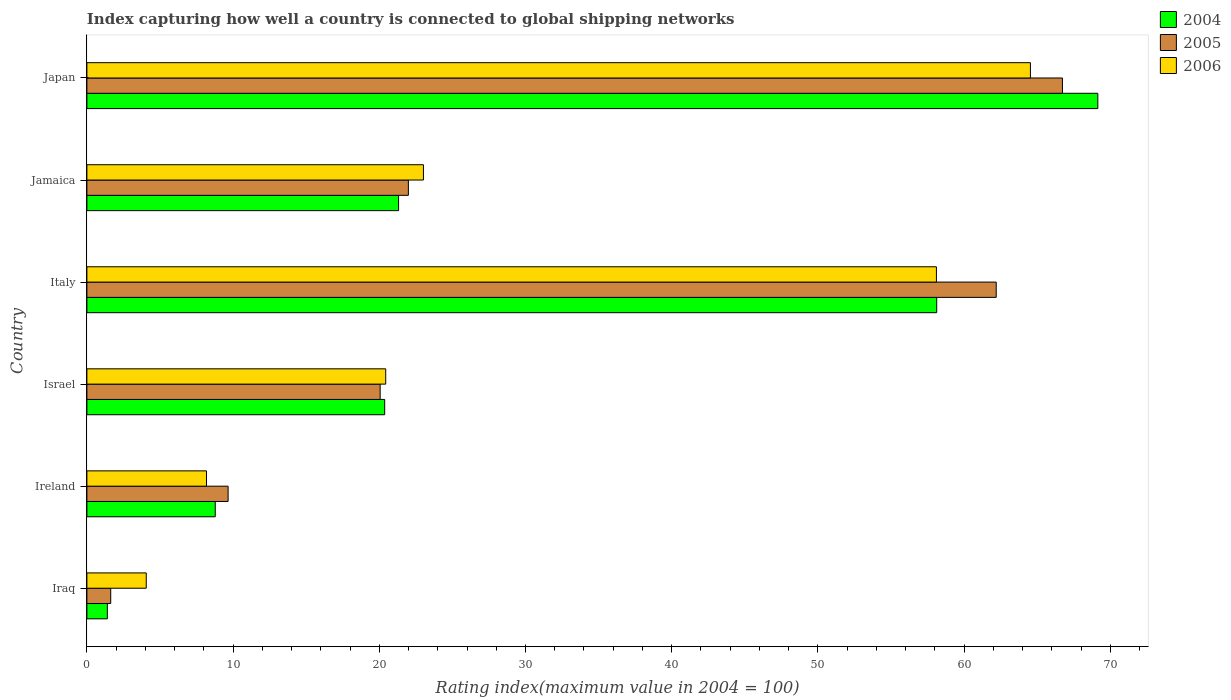How many different coloured bars are there?
Provide a succinct answer. 3. How many groups of bars are there?
Offer a terse response. 6. Are the number of bars on each tick of the Y-axis equal?
Provide a short and direct response. Yes. How many bars are there on the 6th tick from the bottom?
Provide a succinct answer. 3. What is the label of the 6th group of bars from the top?
Give a very brief answer. Iraq. What is the rating index in 2004 in Japan?
Offer a very short reply. 69.15. Across all countries, what is the maximum rating index in 2005?
Provide a short and direct response. 66.73. Across all countries, what is the minimum rating index in 2005?
Your response must be concise. 1.63. In which country was the rating index in 2004 maximum?
Offer a terse response. Japan. In which country was the rating index in 2005 minimum?
Keep it short and to the point. Iraq. What is the total rating index in 2006 in the graph?
Ensure brevity in your answer.  178.35. What is the difference between the rating index in 2004 in Israel and that in Japan?
Make the answer very short. -48.78. What is the difference between the rating index in 2006 in Italy and the rating index in 2005 in Ireland?
Give a very brief answer. 48.45. What is the average rating index in 2006 per country?
Your answer should be very brief. 29.72. What is the difference between the rating index in 2005 and rating index in 2006 in Jamaica?
Provide a short and direct response. -1.03. What is the ratio of the rating index in 2005 in Iraq to that in Jamaica?
Offer a very short reply. 0.07. Is the rating index in 2004 in Israel less than that in Jamaica?
Your answer should be compact. Yes. What is the difference between the highest and the second highest rating index in 2006?
Provide a succinct answer. 6.43. What is the difference between the highest and the lowest rating index in 2006?
Your answer should be very brief. 60.48. In how many countries, is the rating index in 2005 greater than the average rating index in 2005 taken over all countries?
Offer a terse response. 2. Is the sum of the rating index in 2006 in Israel and Jamaica greater than the maximum rating index in 2004 across all countries?
Offer a terse response. No. What does the 2nd bar from the bottom in Iraq represents?
Offer a very short reply. 2005. Is it the case that in every country, the sum of the rating index in 2006 and rating index in 2004 is greater than the rating index in 2005?
Provide a succinct answer. Yes. How many bars are there?
Your answer should be compact. 18. How many countries are there in the graph?
Your response must be concise. 6. Are the values on the major ticks of X-axis written in scientific E-notation?
Give a very brief answer. No. Does the graph contain any zero values?
Offer a terse response. No. What is the title of the graph?
Your answer should be very brief. Index capturing how well a country is connected to global shipping networks. What is the label or title of the X-axis?
Give a very brief answer. Rating index(maximum value in 2004 = 100). What is the Rating index(maximum value in 2004 = 100) of 2004 in Iraq?
Provide a short and direct response. 1.4. What is the Rating index(maximum value in 2004 = 100) in 2005 in Iraq?
Offer a terse response. 1.63. What is the Rating index(maximum value in 2004 = 100) in 2006 in Iraq?
Your answer should be compact. 4.06. What is the Rating index(maximum value in 2004 = 100) of 2004 in Ireland?
Keep it short and to the point. 8.78. What is the Rating index(maximum value in 2004 = 100) in 2005 in Ireland?
Offer a terse response. 9.66. What is the Rating index(maximum value in 2004 = 100) of 2006 in Ireland?
Your response must be concise. 8.18. What is the Rating index(maximum value in 2004 = 100) of 2004 in Israel?
Your answer should be very brief. 20.37. What is the Rating index(maximum value in 2004 = 100) in 2005 in Israel?
Make the answer very short. 20.06. What is the Rating index(maximum value in 2004 = 100) of 2006 in Israel?
Ensure brevity in your answer.  20.44. What is the Rating index(maximum value in 2004 = 100) of 2004 in Italy?
Offer a very short reply. 58.13. What is the Rating index(maximum value in 2004 = 100) of 2005 in Italy?
Your response must be concise. 62.2. What is the Rating index(maximum value in 2004 = 100) in 2006 in Italy?
Ensure brevity in your answer.  58.11. What is the Rating index(maximum value in 2004 = 100) of 2004 in Jamaica?
Offer a terse response. 21.32. What is the Rating index(maximum value in 2004 = 100) in 2005 in Jamaica?
Provide a succinct answer. 21.99. What is the Rating index(maximum value in 2004 = 100) in 2006 in Jamaica?
Your answer should be compact. 23.02. What is the Rating index(maximum value in 2004 = 100) in 2004 in Japan?
Offer a very short reply. 69.15. What is the Rating index(maximum value in 2004 = 100) in 2005 in Japan?
Offer a very short reply. 66.73. What is the Rating index(maximum value in 2004 = 100) in 2006 in Japan?
Keep it short and to the point. 64.54. Across all countries, what is the maximum Rating index(maximum value in 2004 = 100) in 2004?
Your response must be concise. 69.15. Across all countries, what is the maximum Rating index(maximum value in 2004 = 100) of 2005?
Your answer should be very brief. 66.73. Across all countries, what is the maximum Rating index(maximum value in 2004 = 100) in 2006?
Provide a succinct answer. 64.54. Across all countries, what is the minimum Rating index(maximum value in 2004 = 100) in 2005?
Offer a terse response. 1.63. Across all countries, what is the minimum Rating index(maximum value in 2004 = 100) of 2006?
Your answer should be compact. 4.06. What is the total Rating index(maximum value in 2004 = 100) of 2004 in the graph?
Provide a short and direct response. 179.15. What is the total Rating index(maximum value in 2004 = 100) of 2005 in the graph?
Offer a terse response. 182.27. What is the total Rating index(maximum value in 2004 = 100) of 2006 in the graph?
Your answer should be compact. 178.35. What is the difference between the Rating index(maximum value in 2004 = 100) of 2004 in Iraq and that in Ireland?
Your response must be concise. -7.38. What is the difference between the Rating index(maximum value in 2004 = 100) in 2005 in Iraq and that in Ireland?
Ensure brevity in your answer.  -8.03. What is the difference between the Rating index(maximum value in 2004 = 100) in 2006 in Iraq and that in Ireland?
Offer a very short reply. -4.12. What is the difference between the Rating index(maximum value in 2004 = 100) in 2004 in Iraq and that in Israel?
Provide a succinct answer. -18.97. What is the difference between the Rating index(maximum value in 2004 = 100) in 2005 in Iraq and that in Israel?
Give a very brief answer. -18.43. What is the difference between the Rating index(maximum value in 2004 = 100) in 2006 in Iraq and that in Israel?
Your answer should be very brief. -16.38. What is the difference between the Rating index(maximum value in 2004 = 100) in 2004 in Iraq and that in Italy?
Offer a terse response. -56.73. What is the difference between the Rating index(maximum value in 2004 = 100) of 2005 in Iraq and that in Italy?
Your answer should be very brief. -60.57. What is the difference between the Rating index(maximum value in 2004 = 100) of 2006 in Iraq and that in Italy?
Provide a succinct answer. -54.05. What is the difference between the Rating index(maximum value in 2004 = 100) in 2004 in Iraq and that in Jamaica?
Offer a very short reply. -19.92. What is the difference between the Rating index(maximum value in 2004 = 100) of 2005 in Iraq and that in Jamaica?
Offer a very short reply. -20.36. What is the difference between the Rating index(maximum value in 2004 = 100) of 2006 in Iraq and that in Jamaica?
Ensure brevity in your answer.  -18.96. What is the difference between the Rating index(maximum value in 2004 = 100) of 2004 in Iraq and that in Japan?
Give a very brief answer. -67.75. What is the difference between the Rating index(maximum value in 2004 = 100) in 2005 in Iraq and that in Japan?
Your answer should be compact. -65.1. What is the difference between the Rating index(maximum value in 2004 = 100) of 2006 in Iraq and that in Japan?
Offer a terse response. -60.48. What is the difference between the Rating index(maximum value in 2004 = 100) of 2004 in Ireland and that in Israel?
Your answer should be very brief. -11.59. What is the difference between the Rating index(maximum value in 2004 = 100) in 2006 in Ireland and that in Israel?
Your answer should be very brief. -12.26. What is the difference between the Rating index(maximum value in 2004 = 100) of 2004 in Ireland and that in Italy?
Give a very brief answer. -49.35. What is the difference between the Rating index(maximum value in 2004 = 100) of 2005 in Ireland and that in Italy?
Your answer should be compact. -52.54. What is the difference between the Rating index(maximum value in 2004 = 100) in 2006 in Ireland and that in Italy?
Provide a short and direct response. -49.93. What is the difference between the Rating index(maximum value in 2004 = 100) in 2004 in Ireland and that in Jamaica?
Your answer should be very brief. -12.54. What is the difference between the Rating index(maximum value in 2004 = 100) in 2005 in Ireland and that in Jamaica?
Offer a very short reply. -12.33. What is the difference between the Rating index(maximum value in 2004 = 100) of 2006 in Ireland and that in Jamaica?
Your answer should be compact. -14.84. What is the difference between the Rating index(maximum value in 2004 = 100) in 2004 in Ireland and that in Japan?
Your response must be concise. -60.37. What is the difference between the Rating index(maximum value in 2004 = 100) in 2005 in Ireland and that in Japan?
Your response must be concise. -57.07. What is the difference between the Rating index(maximum value in 2004 = 100) in 2006 in Ireland and that in Japan?
Provide a short and direct response. -56.36. What is the difference between the Rating index(maximum value in 2004 = 100) in 2004 in Israel and that in Italy?
Give a very brief answer. -37.76. What is the difference between the Rating index(maximum value in 2004 = 100) in 2005 in Israel and that in Italy?
Your answer should be very brief. -42.14. What is the difference between the Rating index(maximum value in 2004 = 100) in 2006 in Israel and that in Italy?
Your answer should be compact. -37.67. What is the difference between the Rating index(maximum value in 2004 = 100) of 2004 in Israel and that in Jamaica?
Keep it short and to the point. -0.95. What is the difference between the Rating index(maximum value in 2004 = 100) in 2005 in Israel and that in Jamaica?
Your answer should be compact. -1.93. What is the difference between the Rating index(maximum value in 2004 = 100) of 2006 in Israel and that in Jamaica?
Keep it short and to the point. -2.58. What is the difference between the Rating index(maximum value in 2004 = 100) of 2004 in Israel and that in Japan?
Provide a succinct answer. -48.78. What is the difference between the Rating index(maximum value in 2004 = 100) of 2005 in Israel and that in Japan?
Your answer should be compact. -46.67. What is the difference between the Rating index(maximum value in 2004 = 100) of 2006 in Israel and that in Japan?
Your answer should be very brief. -44.1. What is the difference between the Rating index(maximum value in 2004 = 100) in 2004 in Italy and that in Jamaica?
Offer a terse response. 36.81. What is the difference between the Rating index(maximum value in 2004 = 100) of 2005 in Italy and that in Jamaica?
Your answer should be compact. 40.21. What is the difference between the Rating index(maximum value in 2004 = 100) in 2006 in Italy and that in Jamaica?
Your response must be concise. 35.09. What is the difference between the Rating index(maximum value in 2004 = 100) in 2004 in Italy and that in Japan?
Give a very brief answer. -11.02. What is the difference between the Rating index(maximum value in 2004 = 100) of 2005 in Italy and that in Japan?
Provide a succinct answer. -4.53. What is the difference between the Rating index(maximum value in 2004 = 100) in 2006 in Italy and that in Japan?
Provide a short and direct response. -6.43. What is the difference between the Rating index(maximum value in 2004 = 100) of 2004 in Jamaica and that in Japan?
Offer a very short reply. -47.83. What is the difference between the Rating index(maximum value in 2004 = 100) in 2005 in Jamaica and that in Japan?
Provide a short and direct response. -44.74. What is the difference between the Rating index(maximum value in 2004 = 100) of 2006 in Jamaica and that in Japan?
Ensure brevity in your answer.  -41.52. What is the difference between the Rating index(maximum value in 2004 = 100) in 2004 in Iraq and the Rating index(maximum value in 2004 = 100) in 2005 in Ireland?
Offer a terse response. -8.26. What is the difference between the Rating index(maximum value in 2004 = 100) in 2004 in Iraq and the Rating index(maximum value in 2004 = 100) in 2006 in Ireland?
Keep it short and to the point. -6.78. What is the difference between the Rating index(maximum value in 2004 = 100) in 2005 in Iraq and the Rating index(maximum value in 2004 = 100) in 2006 in Ireland?
Give a very brief answer. -6.55. What is the difference between the Rating index(maximum value in 2004 = 100) of 2004 in Iraq and the Rating index(maximum value in 2004 = 100) of 2005 in Israel?
Offer a very short reply. -18.66. What is the difference between the Rating index(maximum value in 2004 = 100) of 2004 in Iraq and the Rating index(maximum value in 2004 = 100) of 2006 in Israel?
Your answer should be compact. -19.04. What is the difference between the Rating index(maximum value in 2004 = 100) in 2005 in Iraq and the Rating index(maximum value in 2004 = 100) in 2006 in Israel?
Ensure brevity in your answer.  -18.81. What is the difference between the Rating index(maximum value in 2004 = 100) of 2004 in Iraq and the Rating index(maximum value in 2004 = 100) of 2005 in Italy?
Offer a very short reply. -60.8. What is the difference between the Rating index(maximum value in 2004 = 100) in 2004 in Iraq and the Rating index(maximum value in 2004 = 100) in 2006 in Italy?
Make the answer very short. -56.71. What is the difference between the Rating index(maximum value in 2004 = 100) of 2005 in Iraq and the Rating index(maximum value in 2004 = 100) of 2006 in Italy?
Offer a very short reply. -56.48. What is the difference between the Rating index(maximum value in 2004 = 100) in 2004 in Iraq and the Rating index(maximum value in 2004 = 100) in 2005 in Jamaica?
Offer a very short reply. -20.59. What is the difference between the Rating index(maximum value in 2004 = 100) of 2004 in Iraq and the Rating index(maximum value in 2004 = 100) of 2006 in Jamaica?
Ensure brevity in your answer.  -21.62. What is the difference between the Rating index(maximum value in 2004 = 100) in 2005 in Iraq and the Rating index(maximum value in 2004 = 100) in 2006 in Jamaica?
Ensure brevity in your answer.  -21.39. What is the difference between the Rating index(maximum value in 2004 = 100) of 2004 in Iraq and the Rating index(maximum value in 2004 = 100) of 2005 in Japan?
Give a very brief answer. -65.33. What is the difference between the Rating index(maximum value in 2004 = 100) in 2004 in Iraq and the Rating index(maximum value in 2004 = 100) in 2006 in Japan?
Keep it short and to the point. -63.14. What is the difference between the Rating index(maximum value in 2004 = 100) in 2005 in Iraq and the Rating index(maximum value in 2004 = 100) in 2006 in Japan?
Your answer should be compact. -62.91. What is the difference between the Rating index(maximum value in 2004 = 100) of 2004 in Ireland and the Rating index(maximum value in 2004 = 100) of 2005 in Israel?
Make the answer very short. -11.28. What is the difference between the Rating index(maximum value in 2004 = 100) in 2004 in Ireland and the Rating index(maximum value in 2004 = 100) in 2006 in Israel?
Offer a terse response. -11.66. What is the difference between the Rating index(maximum value in 2004 = 100) in 2005 in Ireland and the Rating index(maximum value in 2004 = 100) in 2006 in Israel?
Offer a terse response. -10.78. What is the difference between the Rating index(maximum value in 2004 = 100) of 2004 in Ireland and the Rating index(maximum value in 2004 = 100) of 2005 in Italy?
Ensure brevity in your answer.  -53.42. What is the difference between the Rating index(maximum value in 2004 = 100) of 2004 in Ireland and the Rating index(maximum value in 2004 = 100) of 2006 in Italy?
Your answer should be compact. -49.33. What is the difference between the Rating index(maximum value in 2004 = 100) in 2005 in Ireland and the Rating index(maximum value in 2004 = 100) in 2006 in Italy?
Provide a succinct answer. -48.45. What is the difference between the Rating index(maximum value in 2004 = 100) of 2004 in Ireland and the Rating index(maximum value in 2004 = 100) of 2005 in Jamaica?
Your answer should be very brief. -13.21. What is the difference between the Rating index(maximum value in 2004 = 100) of 2004 in Ireland and the Rating index(maximum value in 2004 = 100) of 2006 in Jamaica?
Offer a terse response. -14.24. What is the difference between the Rating index(maximum value in 2004 = 100) in 2005 in Ireland and the Rating index(maximum value in 2004 = 100) in 2006 in Jamaica?
Your response must be concise. -13.36. What is the difference between the Rating index(maximum value in 2004 = 100) in 2004 in Ireland and the Rating index(maximum value in 2004 = 100) in 2005 in Japan?
Your answer should be very brief. -57.95. What is the difference between the Rating index(maximum value in 2004 = 100) of 2004 in Ireland and the Rating index(maximum value in 2004 = 100) of 2006 in Japan?
Offer a very short reply. -55.76. What is the difference between the Rating index(maximum value in 2004 = 100) of 2005 in Ireland and the Rating index(maximum value in 2004 = 100) of 2006 in Japan?
Your answer should be very brief. -54.88. What is the difference between the Rating index(maximum value in 2004 = 100) in 2004 in Israel and the Rating index(maximum value in 2004 = 100) in 2005 in Italy?
Provide a succinct answer. -41.83. What is the difference between the Rating index(maximum value in 2004 = 100) of 2004 in Israel and the Rating index(maximum value in 2004 = 100) of 2006 in Italy?
Provide a short and direct response. -37.74. What is the difference between the Rating index(maximum value in 2004 = 100) in 2005 in Israel and the Rating index(maximum value in 2004 = 100) in 2006 in Italy?
Keep it short and to the point. -38.05. What is the difference between the Rating index(maximum value in 2004 = 100) in 2004 in Israel and the Rating index(maximum value in 2004 = 100) in 2005 in Jamaica?
Ensure brevity in your answer.  -1.62. What is the difference between the Rating index(maximum value in 2004 = 100) of 2004 in Israel and the Rating index(maximum value in 2004 = 100) of 2006 in Jamaica?
Your answer should be compact. -2.65. What is the difference between the Rating index(maximum value in 2004 = 100) in 2005 in Israel and the Rating index(maximum value in 2004 = 100) in 2006 in Jamaica?
Offer a very short reply. -2.96. What is the difference between the Rating index(maximum value in 2004 = 100) in 2004 in Israel and the Rating index(maximum value in 2004 = 100) in 2005 in Japan?
Offer a very short reply. -46.36. What is the difference between the Rating index(maximum value in 2004 = 100) in 2004 in Israel and the Rating index(maximum value in 2004 = 100) in 2006 in Japan?
Provide a short and direct response. -44.17. What is the difference between the Rating index(maximum value in 2004 = 100) in 2005 in Israel and the Rating index(maximum value in 2004 = 100) in 2006 in Japan?
Give a very brief answer. -44.48. What is the difference between the Rating index(maximum value in 2004 = 100) in 2004 in Italy and the Rating index(maximum value in 2004 = 100) in 2005 in Jamaica?
Keep it short and to the point. 36.14. What is the difference between the Rating index(maximum value in 2004 = 100) of 2004 in Italy and the Rating index(maximum value in 2004 = 100) of 2006 in Jamaica?
Offer a very short reply. 35.11. What is the difference between the Rating index(maximum value in 2004 = 100) in 2005 in Italy and the Rating index(maximum value in 2004 = 100) in 2006 in Jamaica?
Keep it short and to the point. 39.18. What is the difference between the Rating index(maximum value in 2004 = 100) of 2004 in Italy and the Rating index(maximum value in 2004 = 100) of 2006 in Japan?
Ensure brevity in your answer.  -6.41. What is the difference between the Rating index(maximum value in 2004 = 100) in 2005 in Italy and the Rating index(maximum value in 2004 = 100) in 2006 in Japan?
Offer a terse response. -2.34. What is the difference between the Rating index(maximum value in 2004 = 100) of 2004 in Jamaica and the Rating index(maximum value in 2004 = 100) of 2005 in Japan?
Your answer should be compact. -45.41. What is the difference between the Rating index(maximum value in 2004 = 100) of 2004 in Jamaica and the Rating index(maximum value in 2004 = 100) of 2006 in Japan?
Your answer should be compact. -43.22. What is the difference between the Rating index(maximum value in 2004 = 100) of 2005 in Jamaica and the Rating index(maximum value in 2004 = 100) of 2006 in Japan?
Give a very brief answer. -42.55. What is the average Rating index(maximum value in 2004 = 100) of 2004 per country?
Make the answer very short. 29.86. What is the average Rating index(maximum value in 2004 = 100) in 2005 per country?
Make the answer very short. 30.38. What is the average Rating index(maximum value in 2004 = 100) in 2006 per country?
Make the answer very short. 29.73. What is the difference between the Rating index(maximum value in 2004 = 100) in 2004 and Rating index(maximum value in 2004 = 100) in 2005 in Iraq?
Your answer should be compact. -0.23. What is the difference between the Rating index(maximum value in 2004 = 100) in 2004 and Rating index(maximum value in 2004 = 100) in 2006 in Iraq?
Offer a terse response. -2.66. What is the difference between the Rating index(maximum value in 2004 = 100) of 2005 and Rating index(maximum value in 2004 = 100) of 2006 in Iraq?
Your answer should be compact. -2.43. What is the difference between the Rating index(maximum value in 2004 = 100) of 2004 and Rating index(maximum value in 2004 = 100) of 2005 in Ireland?
Your answer should be compact. -0.88. What is the difference between the Rating index(maximum value in 2004 = 100) in 2005 and Rating index(maximum value in 2004 = 100) in 2006 in Ireland?
Offer a very short reply. 1.48. What is the difference between the Rating index(maximum value in 2004 = 100) of 2004 and Rating index(maximum value in 2004 = 100) of 2005 in Israel?
Your answer should be very brief. 0.31. What is the difference between the Rating index(maximum value in 2004 = 100) in 2004 and Rating index(maximum value in 2004 = 100) in 2006 in Israel?
Keep it short and to the point. -0.07. What is the difference between the Rating index(maximum value in 2004 = 100) in 2005 and Rating index(maximum value in 2004 = 100) in 2006 in Israel?
Provide a short and direct response. -0.38. What is the difference between the Rating index(maximum value in 2004 = 100) in 2004 and Rating index(maximum value in 2004 = 100) in 2005 in Italy?
Make the answer very short. -4.07. What is the difference between the Rating index(maximum value in 2004 = 100) in 2004 and Rating index(maximum value in 2004 = 100) in 2006 in Italy?
Your answer should be very brief. 0.02. What is the difference between the Rating index(maximum value in 2004 = 100) of 2005 and Rating index(maximum value in 2004 = 100) of 2006 in Italy?
Provide a succinct answer. 4.09. What is the difference between the Rating index(maximum value in 2004 = 100) of 2004 and Rating index(maximum value in 2004 = 100) of 2005 in Jamaica?
Your answer should be compact. -0.67. What is the difference between the Rating index(maximum value in 2004 = 100) in 2004 and Rating index(maximum value in 2004 = 100) in 2006 in Jamaica?
Keep it short and to the point. -1.7. What is the difference between the Rating index(maximum value in 2004 = 100) of 2005 and Rating index(maximum value in 2004 = 100) of 2006 in Jamaica?
Your answer should be compact. -1.03. What is the difference between the Rating index(maximum value in 2004 = 100) of 2004 and Rating index(maximum value in 2004 = 100) of 2005 in Japan?
Provide a short and direct response. 2.42. What is the difference between the Rating index(maximum value in 2004 = 100) in 2004 and Rating index(maximum value in 2004 = 100) in 2006 in Japan?
Your answer should be compact. 4.61. What is the difference between the Rating index(maximum value in 2004 = 100) of 2005 and Rating index(maximum value in 2004 = 100) of 2006 in Japan?
Give a very brief answer. 2.19. What is the ratio of the Rating index(maximum value in 2004 = 100) in 2004 in Iraq to that in Ireland?
Give a very brief answer. 0.16. What is the ratio of the Rating index(maximum value in 2004 = 100) of 2005 in Iraq to that in Ireland?
Your answer should be compact. 0.17. What is the ratio of the Rating index(maximum value in 2004 = 100) in 2006 in Iraq to that in Ireland?
Provide a succinct answer. 0.5. What is the ratio of the Rating index(maximum value in 2004 = 100) in 2004 in Iraq to that in Israel?
Keep it short and to the point. 0.07. What is the ratio of the Rating index(maximum value in 2004 = 100) in 2005 in Iraq to that in Israel?
Make the answer very short. 0.08. What is the ratio of the Rating index(maximum value in 2004 = 100) in 2006 in Iraq to that in Israel?
Ensure brevity in your answer.  0.2. What is the ratio of the Rating index(maximum value in 2004 = 100) of 2004 in Iraq to that in Italy?
Provide a succinct answer. 0.02. What is the ratio of the Rating index(maximum value in 2004 = 100) of 2005 in Iraq to that in Italy?
Make the answer very short. 0.03. What is the ratio of the Rating index(maximum value in 2004 = 100) of 2006 in Iraq to that in Italy?
Offer a terse response. 0.07. What is the ratio of the Rating index(maximum value in 2004 = 100) in 2004 in Iraq to that in Jamaica?
Ensure brevity in your answer.  0.07. What is the ratio of the Rating index(maximum value in 2004 = 100) in 2005 in Iraq to that in Jamaica?
Give a very brief answer. 0.07. What is the ratio of the Rating index(maximum value in 2004 = 100) in 2006 in Iraq to that in Jamaica?
Provide a short and direct response. 0.18. What is the ratio of the Rating index(maximum value in 2004 = 100) of 2004 in Iraq to that in Japan?
Offer a terse response. 0.02. What is the ratio of the Rating index(maximum value in 2004 = 100) of 2005 in Iraq to that in Japan?
Keep it short and to the point. 0.02. What is the ratio of the Rating index(maximum value in 2004 = 100) of 2006 in Iraq to that in Japan?
Your response must be concise. 0.06. What is the ratio of the Rating index(maximum value in 2004 = 100) of 2004 in Ireland to that in Israel?
Provide a succinct answer. 0.43. What is the ratio of the Rating index(maximum value in 2004 = 100) in 2005 in Ireland to that in Israel?
Your answer should be compact. 0.48. What is the ratio of the Rating index(maximum value in 2004 = 100) of 2006 in Ireland to that in Israel?
Provide a succinct answer. 0.4. What is the ratio of the Rating index(maximum value in 2004 = 100) of 2004 in Ireland to that in Italy?
Your answer should be very brief. 0.15. What is the ratio of the Rating index(maximum value in 2004 = 100) in 2005 in Ireland to that in Italy?
Your response must be concise. 0.16. What is the ratio of the Rating index(maximum value in 2004 = 100) in 2006 in Ireland to that in Italy?
Ensure brevity in your answer.  0.14. What is the ratio of the Rating index(maximum value in 2004 = 100) of 2004 in Ireland to that in Jamaica?
Your answer should be compact. 0.41. What is the ratio of the Rating index(maximum value in 2004 = 100) in 2005 in Ireland to that in Jamaica?
Keep it short and to the point. 0.44. What is the ratio of the Rating index(maximum value in 2004 = 100) in 2006 in Ireland to that in Jamaica?
Your answer should be compact. 0.36. What is the ratio of the Rating index(maximum value in 2004 = 100) of 2004 in Ireland to that in Japan?
Your answer should be very brief. 0.13. What is the ratio of the Rating index(maximum value in 2004 = 100) of 2005 in Ireland to that in Japan?
Ensure brevity in your answer.  0.14. What is the ratio of the Rating index(maximum value in 2004 = 100) of 2006 in Ireland to that in Japan?
Make the answer very short. 0.13. What is the ratio of the Rating index(maximum value in 2004 = 100) of 2004 in Israel to that in Italy?
Offer a terse response. 0.35. What is the ratio of the Rating index(maximum value in 2004 = 100) of 2005 in Israel to that in Italy?
Provide a succinct answer. 0.32. What is the ratio of the Rating index(maximum value in 2004 = 100) of 2006 in Israel to that in Italy?
Offer a terse response. 0.35. What is the ratio of the Rating index(maximum value in 2004 = 100) in 2004 in Israel to that in Jamaica?
Make the answer very short. 0.96. What is the ratio of the Rating index(maximum value in 2004 = 100) in 2005 in Israel to that in Jamaica?
Provide a succinct answer. 0.91. What is the ratio of the Rating index(maximum value in 2004 = 100) in 2006 in Israel to that in Jamaica?
Make the answer very short. 0.89. What is the ratio of the Rating index(maximum value in 2004 = 100) in 2004 in Israel to that in Japan?
Make the answer very short. 0.29. What is the ratio of the Rating index(maximum value in 2004 = 100) of 2005 in Israel to that in Japan?
Offer a terse response. 0.3. What is the ratio of the Rating index(maximum value in 2004 = 100) of 2006 in Israel to that in Japan?
Give a very brief answer. 0.32. What is the ratio of the Rating index(maximum value in 2004 = 100) in 2004 in Italy to that in Jamaica?
Keep it short and to the point. 2.73. What is the ratio of the Rating index(maximum value in 2004 = 100) in 2005 in Italy to that in Jamaica?
Your answer should be very brief. 2.83. What is the ratio of the Rating index(maximum value in 2004 = 100) in 2006 in Italy to that in Jamaica?
Make the answer very short. 2.52. What is the ratio of the Rating index(maximum value in 2004 = 100) in 2004 in Italy to that in Japan?
Your answer should be very brief. 0.84. What is the ratio of the Rating index(maximum value in 2004 = 100) in 2005 in Italy to that in Japan?
Your response must be concise. 0.93. What is the ratio of the Rating index(maximum value in 2004 = 100) in 2006 in Italy to that in Japan?
Offer a very short reply. 0.9. What is the ratio of the Rating index(maximum value in 2004 = 100) in 2004 in Jamaica to that in Japan?
Offer a terse response. 0.31. What is the ratio of the Rating index(maximum value in 2004 = 100) of 2005 in Jamaica to that in Japan?
Your response must be concise. 0.33. What is the ratio of the Rating index(maximum value in 2004 = 100) in 2006 in Jamaica to that in Japan?
Provide a short and direct response. 0.36. What is the difference between the highest and the second highest Rating index(maximum value in 2004 = 100) of 2004?
Your answer should be compact. 11.02. What is the difference between the highest and the second highest Rating index(maximum value in 2004 = 100) of 2005?
Keep it short and to the point. 4.53. What is the difference between the highest and the second highest Rating index(maximum value in 2004 = 100) of 2006?
Keep it short and to the point. 6.43. What is the difference between the highest and the lowest Rating index(maximum value in 2004 = 100) of 2004?
Give a very brief answer. 67.75. What is the difference between the highest and the lowest Rating index(maximum value in 2004 = 100) in 2005?
Keep it short and to the point. 65.1. What is the difference between the highest and the lowest Rating index(maximum value in 2004 = 100) of 2006?
Your answer should be very brief. 60.48. 